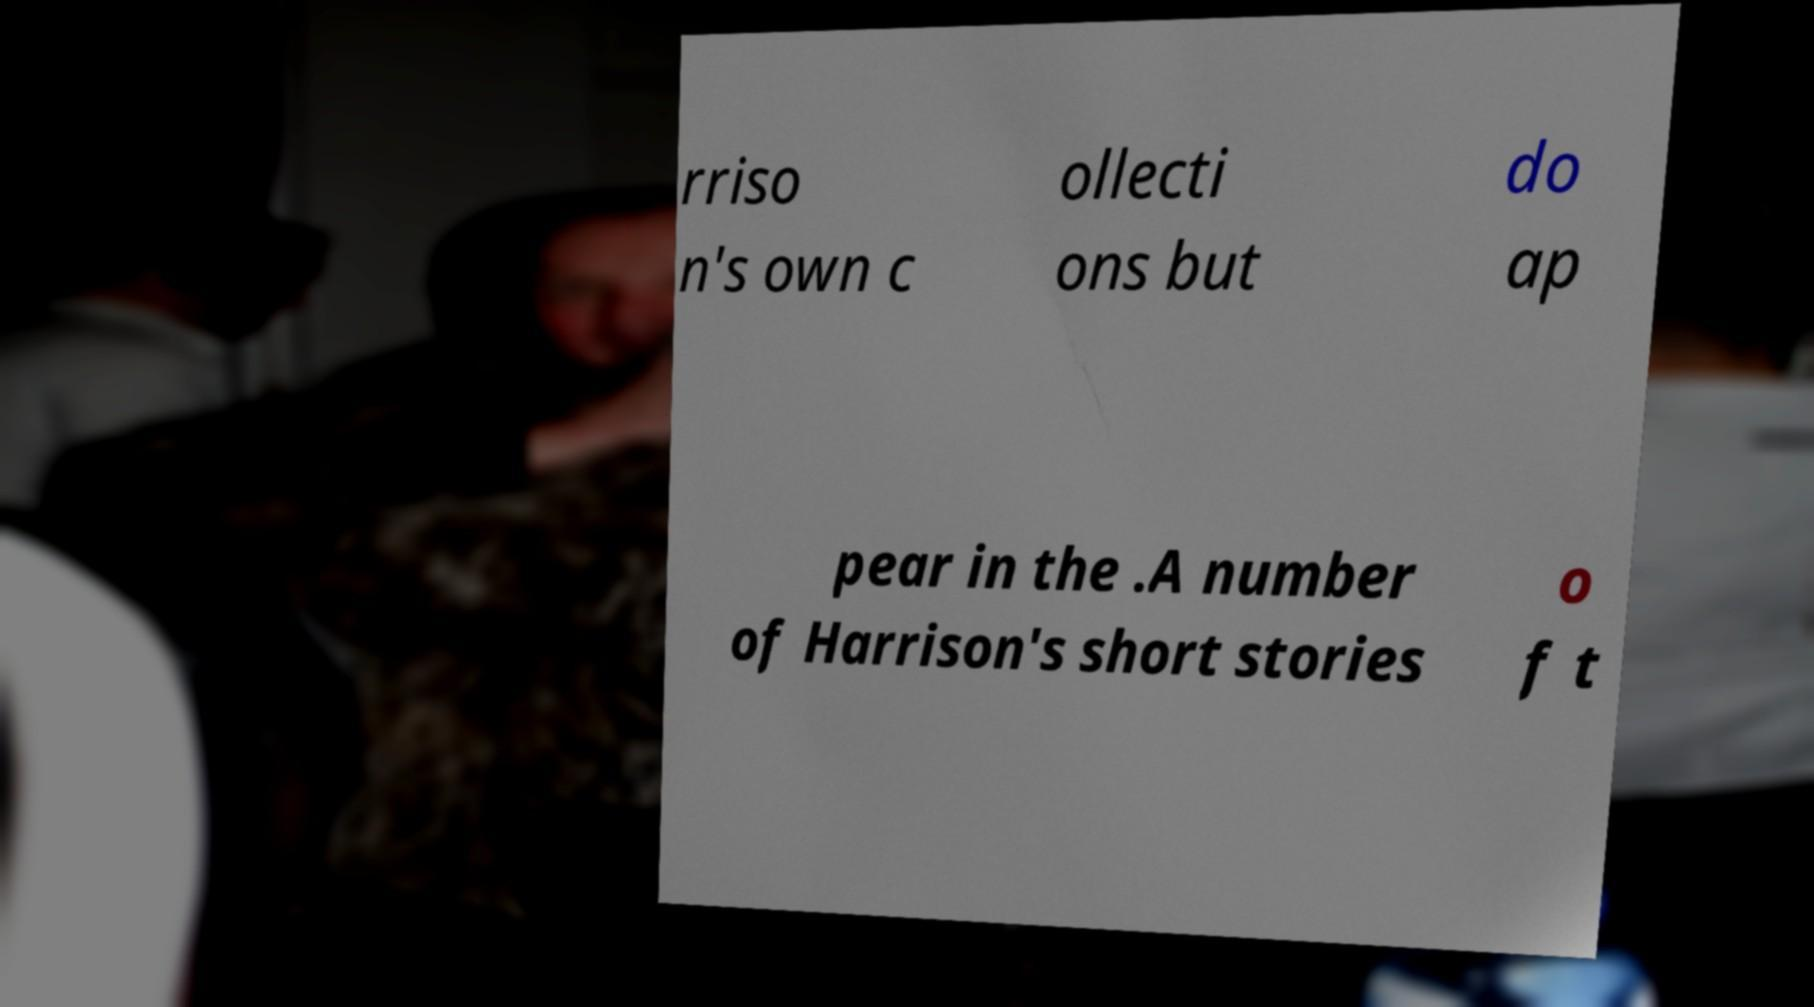Please read and relay the text visible in this image. What does it say? rriso n's own c ollecti ons but do ap pear in the .A number of Harrison's short stories o f t 